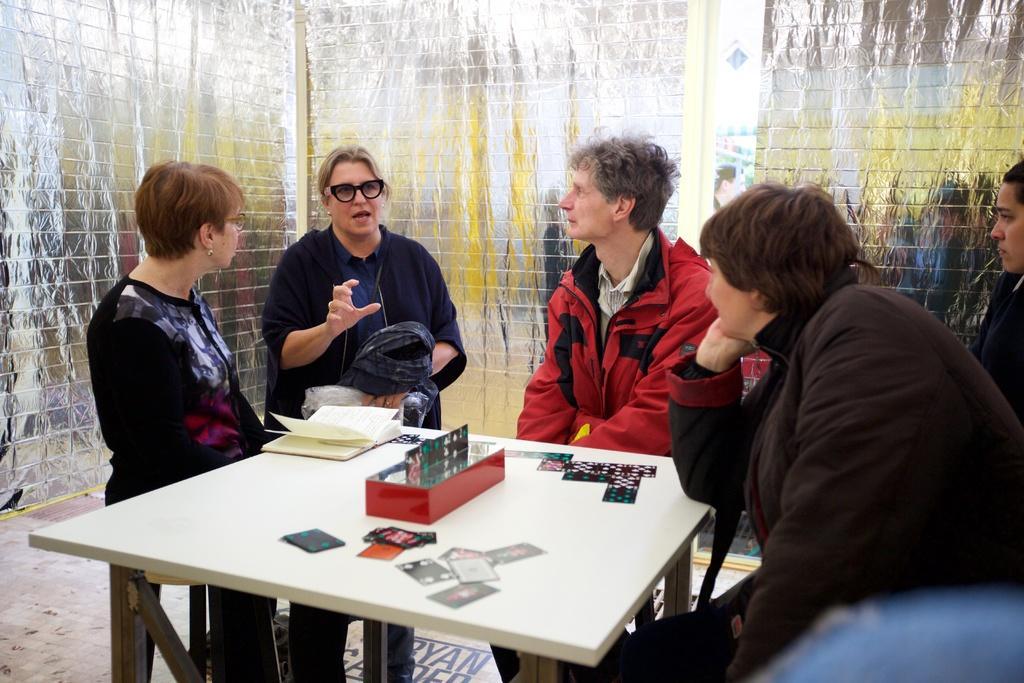How would you summarize this image in a sentence or two? 4 people are present across the table. there are book and a box present. the person at the center is standing and speaking. there are 3 people who are sitting on the chairs. behind them there is a silver wall. 